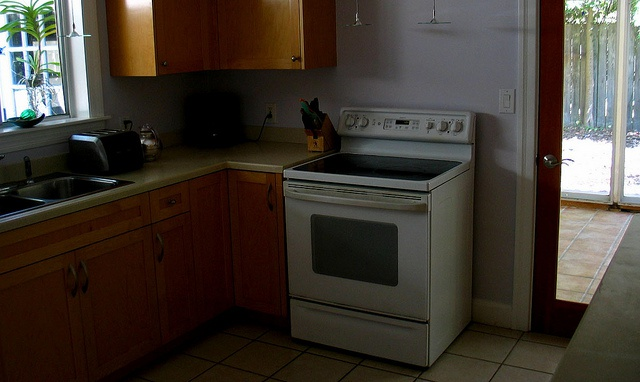Describe the objects in this image and their specific colors. I can see oven in white, black, and gray tones, potted plant in white, gray, darkgray, and lightblue tones, toaster in white, black, gray, and lightblue tones, sink in white, black, gray, darkgray, and blue tones, and vase in white, lightblue, gray, and darkgray tones in this image. 